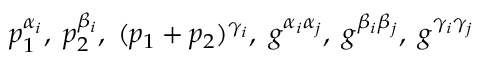Convert formula to latex. <formula><loc_0><loc_0><loc_500><loc_500>p _ { 1 } ^ { \alpha _ { i } } , \, p _ { 2 } ^ { \beta _ { i } } , \, ( p _ { 1 } + p _ { 2 } ) ^ { \gamma _ { i } } , \, g ^ { \alpha _ { i } \alpha _ { j } } , \, g ^ { \beta _ { i } \beta _ { j } } , \, g ^ { \gamma _ { i } \gamma _ { j } }</formula> 